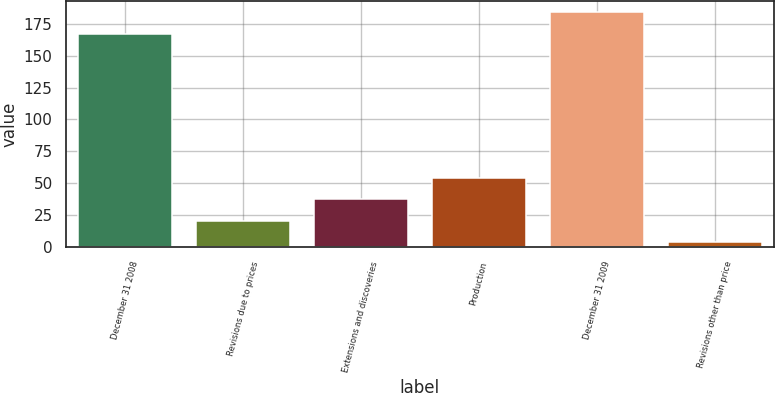<chart> <loc_0><loc_0><loc_500><loc_500><bar_chart><fcel>December 31 2008<fcel>Revisions due to prices<fcel>Extensions and discoveries<fcel>Production<fcel>December 31 2009<fcel>Revisions other than price<nl><fcel>167<fcel>20.8<fcel>37.6<fcel>54.4<fcel>183.8<fcel>4<nl></chart> 